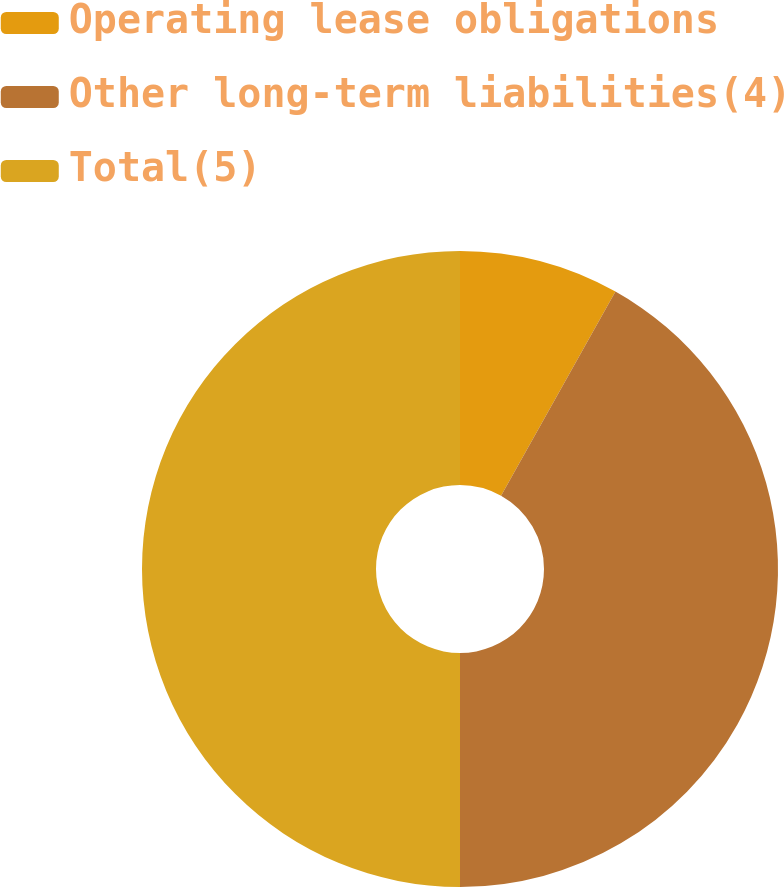<chart> <loc_0><loc_0><loc_500><loc_500><pie_chart><fcel>Operating lease obligations<fcel>Other long-term liabilities(4)<fcel>Total(5)<nl><fcel>8.13%<fcel>41.87%<fcel>50.0%<nl></chart> 